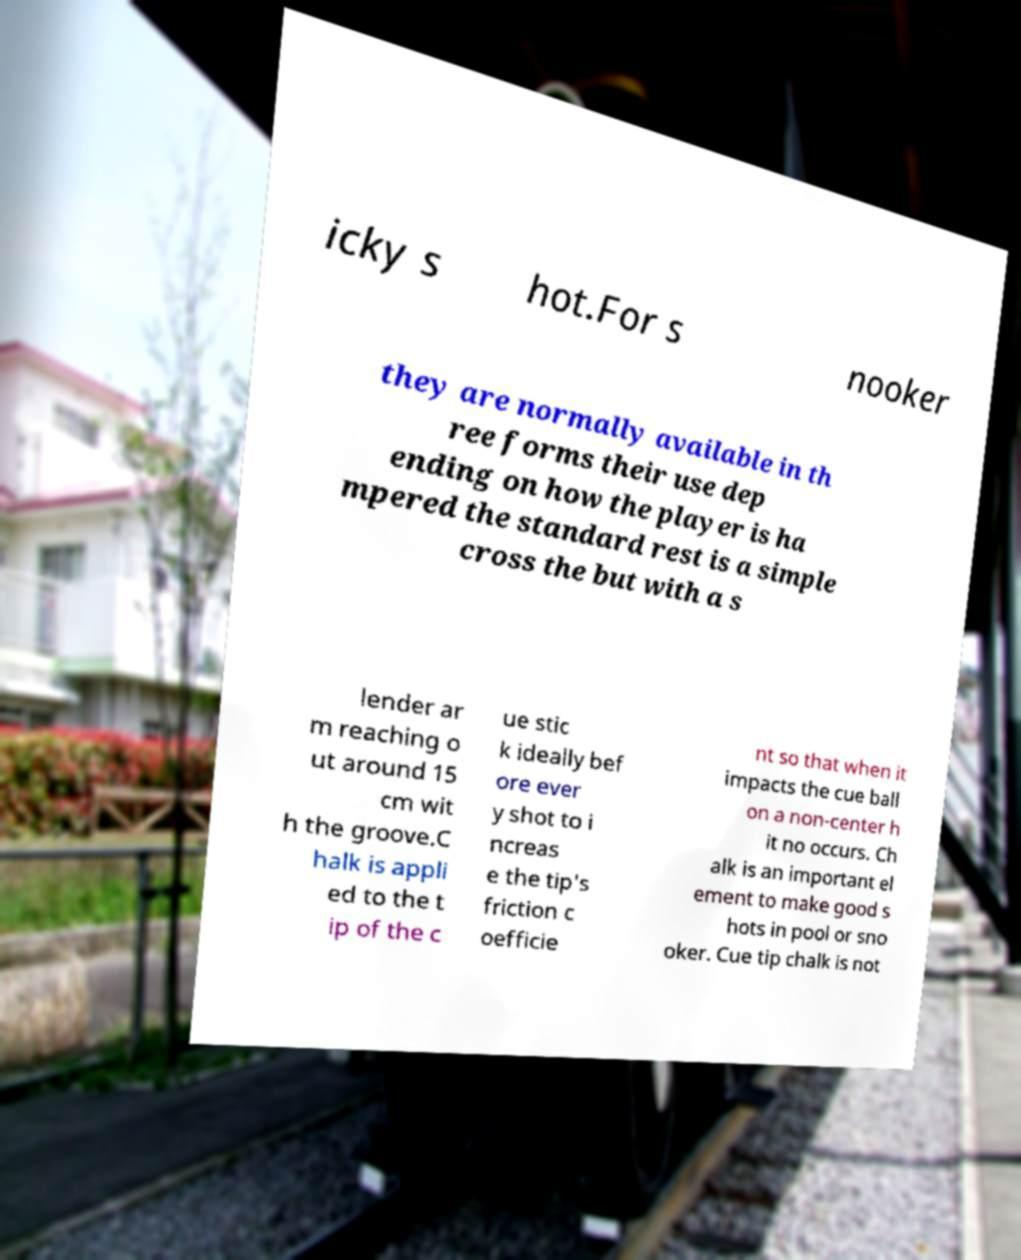Can you read and provide the text displayed in the image?This photo seems to have some interesting text. Can you extract and type it out for me? icky s hot.For s nooker they are normally available in th ree forms their use dep ending on how the player is ha mpered the standard rest is a simple cross the but with a s lender ar m reaching o ut around 15 cm wit h the groove.C halk is appli ed to the t ip of the c ue stic k ideally bef ore ever y shot to i ncreas e the tip's friction c oefficie nt so that when it impacts the cue ball on a non-center h it no occurs. Ch alk is an important el ement to make good s hots in pool or sno oker. Cue tip chalk is not 